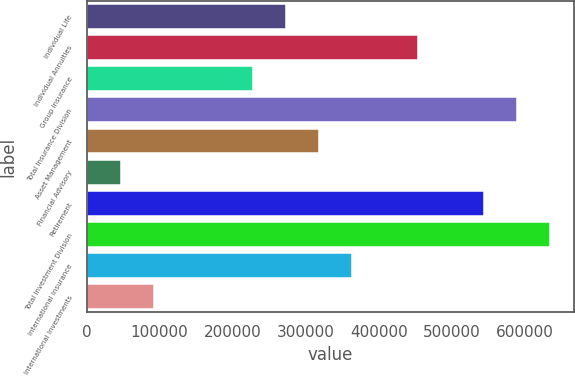Convert chart to OTSL. <chart><loc_0><loc_0><loc_500><loc_500><bar_chart><fcel>Individual Life<fcel>Individual Annuities<fcel>Group Insurance<fcel>Total Insurance Division<fcel>Asset Management<fcel>Financial Advisory<fcel>Retirement<fcel>Total Investment Division<fcel>International Insurance<fcel>International Investments<nl><fcel>273112<fcel>454266<fcel>227823<fcel>590132<fcel>318400<fcel>46668.6<fcel>544843<fcel>635420<fcel>363689<fcel>91957.2<nl></chart> 